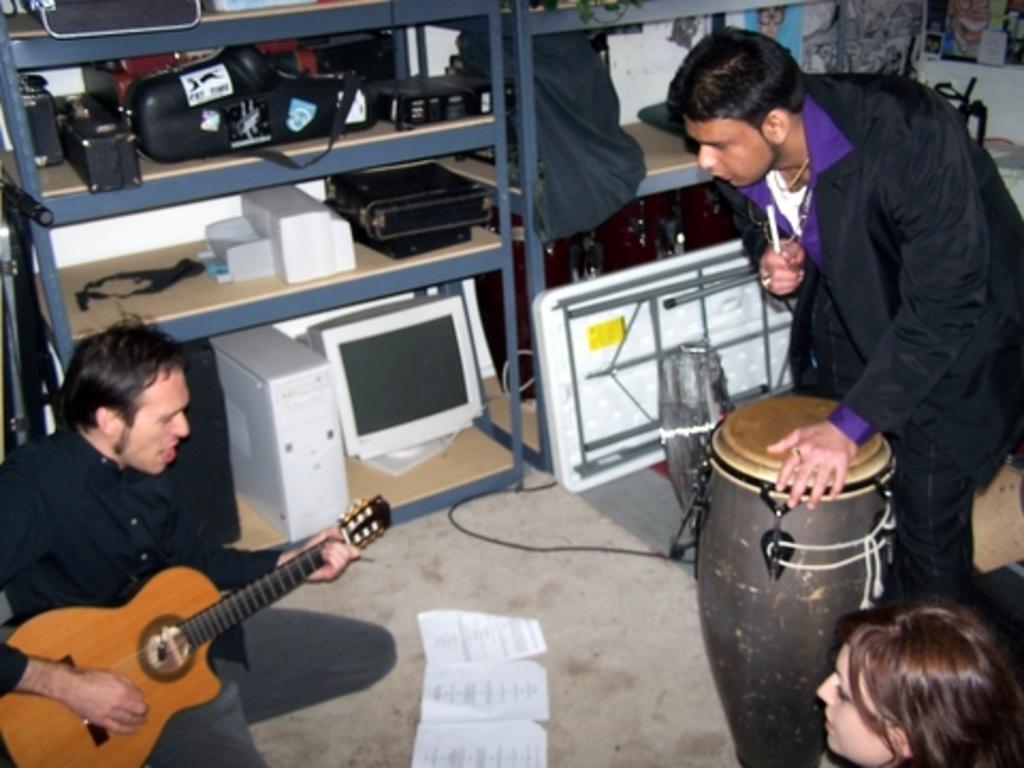Please provide a concise description of this image. 3 people are present in a room. the person at the left is sitting and playing guitar. the person at the right is standing, wearing black suit. his hand is on the drum. in the center there are papers on the floor. behind them there are shelves in which there are computer, c. p. u, bag and other objects. 